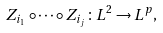<formula> <loc_0><loc_0><loc_500><loc_500>Z _ { i _ { 1 } } \circ \cdots \circ Z _ { i _ { j } } \colon L ^ { 2 } \rightarrow L ^ { p } ,</formula> 